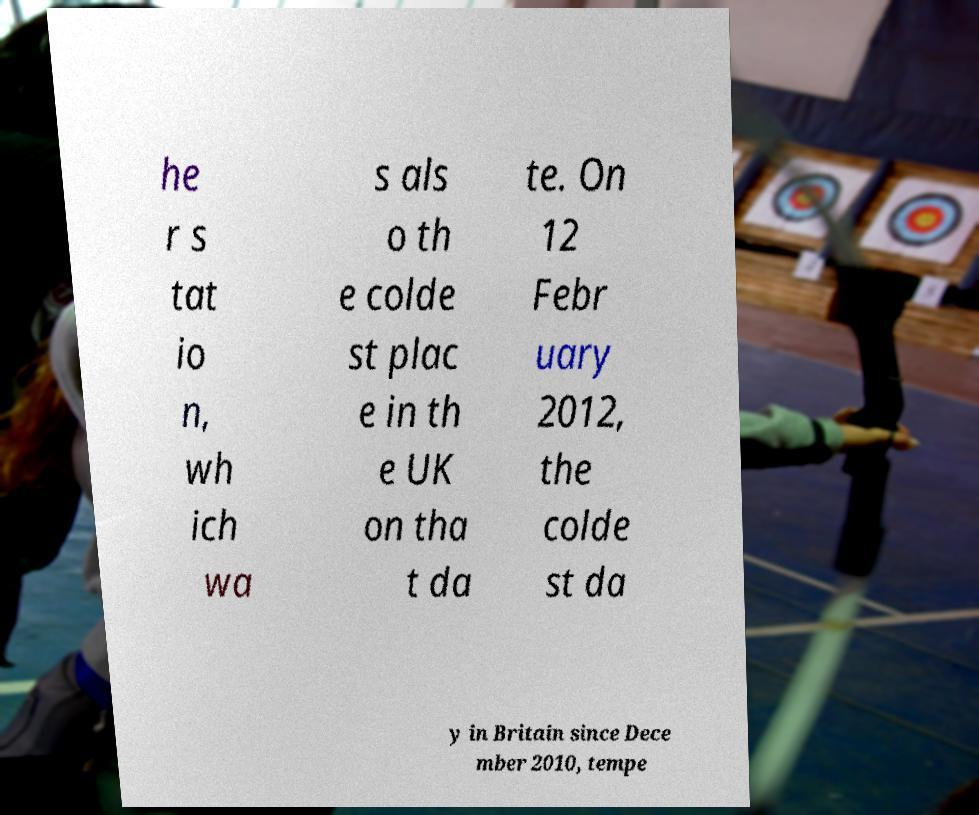For documentation purposes, I need the text within this image transcribed. Could you provide that? he r s tat io n, wh ich wa s als o th e colde st plac e in th e UK on tha t da te. On 12 Febr uary 2012, the colde st da y in Britain since Dece mber 2010, tempe 